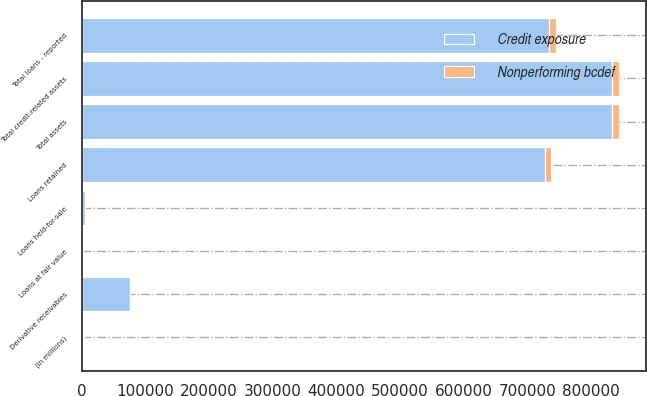<chart> <loc_0><loc_0><loc_500><loc_500><stacked_bar_chart><ecel><fcel>(in millions)<fcel>Loans retained<fcel>Loans held-for-sale<fcel>Loans at fair value<fcel>Total loans - reported<fcel>Derivative receivables<fcel>Total credit-related assets<fcel>Total assets<nl><fcel>Credit exposure<fcel>2012<fcel>726835<fcel>4406<fcel>2555<fcel>733796<fcel>74983<fcel>832540<fcel>832540<nl><fcel>Nonperforming bcdef<fcel>2012<fcel>10609<fcel>18<fcel>93<fcel>10720<fcel>239<fcel>10959<fcel>11734<nl></chart> 